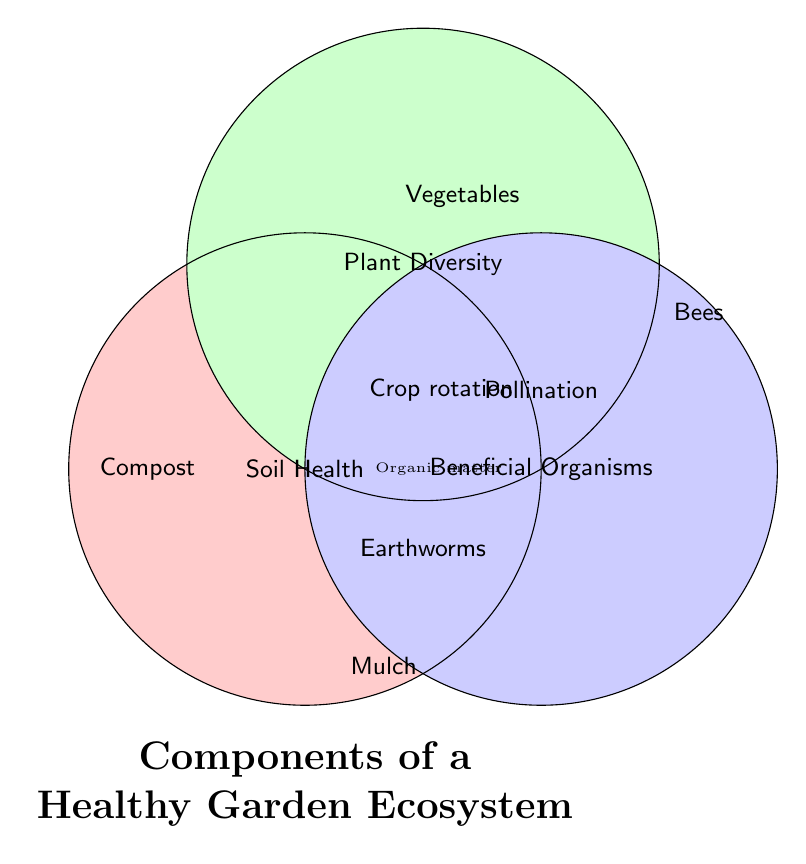What is the title of the Venn diagram? The title is located at the bottom of the Venn diagram and is written in large, bold font.
Answer: "Components of a Healthy Garden Ecosystem" What color is used for the "Soil Health" section? The "Soil Health" section is filled with a color. This color is visually distinct and is a shade of red.
Answer: Red Which elements are specifically in the “Plant Diversity” section but not in any intersections? These elements are positioned within the Venn diagram's "Plant Diversity" section but not in the overlapping areas.
Answer: Vegetables, Herbs, Flowers What categories intersect with "Earthworms"? Determining the categories that have "Earthworms" involves finding which parts of the Venn diagram overlap with its location. "Earthworms" lies in the overlap between "Soil Health" and "Beneficial Organisms".
Answer: Soil Health and Beneficial Organisms What is the overlap between all three categories? The overlap between all three circles in the Venn diagram is the intersection of all three categories, displaying the most comprehensive elements.
Answer: Organic matter Which category includes 'Pollination'? "Pollination" is placed in a specific section that overlaps between categories. It lies in the intersection between "Plant Diversity" and "Beneficial Organisms".
Answer: Plant Diversity and Beneficial Organisms List two elements unique to the "Soil Health" category. These elements are placed specifically within the "Soil Health" circle and are not part of any intersections.
Answer: Compost and Mulch Which elements are found in both "Soil Health" and "Plant Diversity" but not in "Beneficial Organisms"? Identifying this requires locating elements in the intersection of "Soil Health" and "Plant Diversity" excluding the overlap with "Beneficial Organisms".
Answer: Crop rotation What elements can you find in the intersection of "Plant Diversity" and "Beneficial Organisms"? This requires identifying the elements in the shared area between these two categories.
Answer: Pollination and Companion planting How many elements are represented in the only "Beneficial Organisms" section? Count the elements positioned only within the "Beneficial Organisms" circle.
Answer: Three elements (Ladybugs, Bees, Birds) 